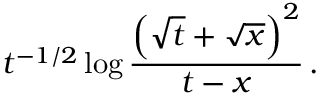Convert formula to latex. <formula><loc_0><loc_0><loc_500><loc_500>t ^ { - 1 / 2 } \log { \frac { \left ( \sqrt { t } + \sqrt { x } \right ) ^ { 2 } } { t - x } } \, .</formula> 